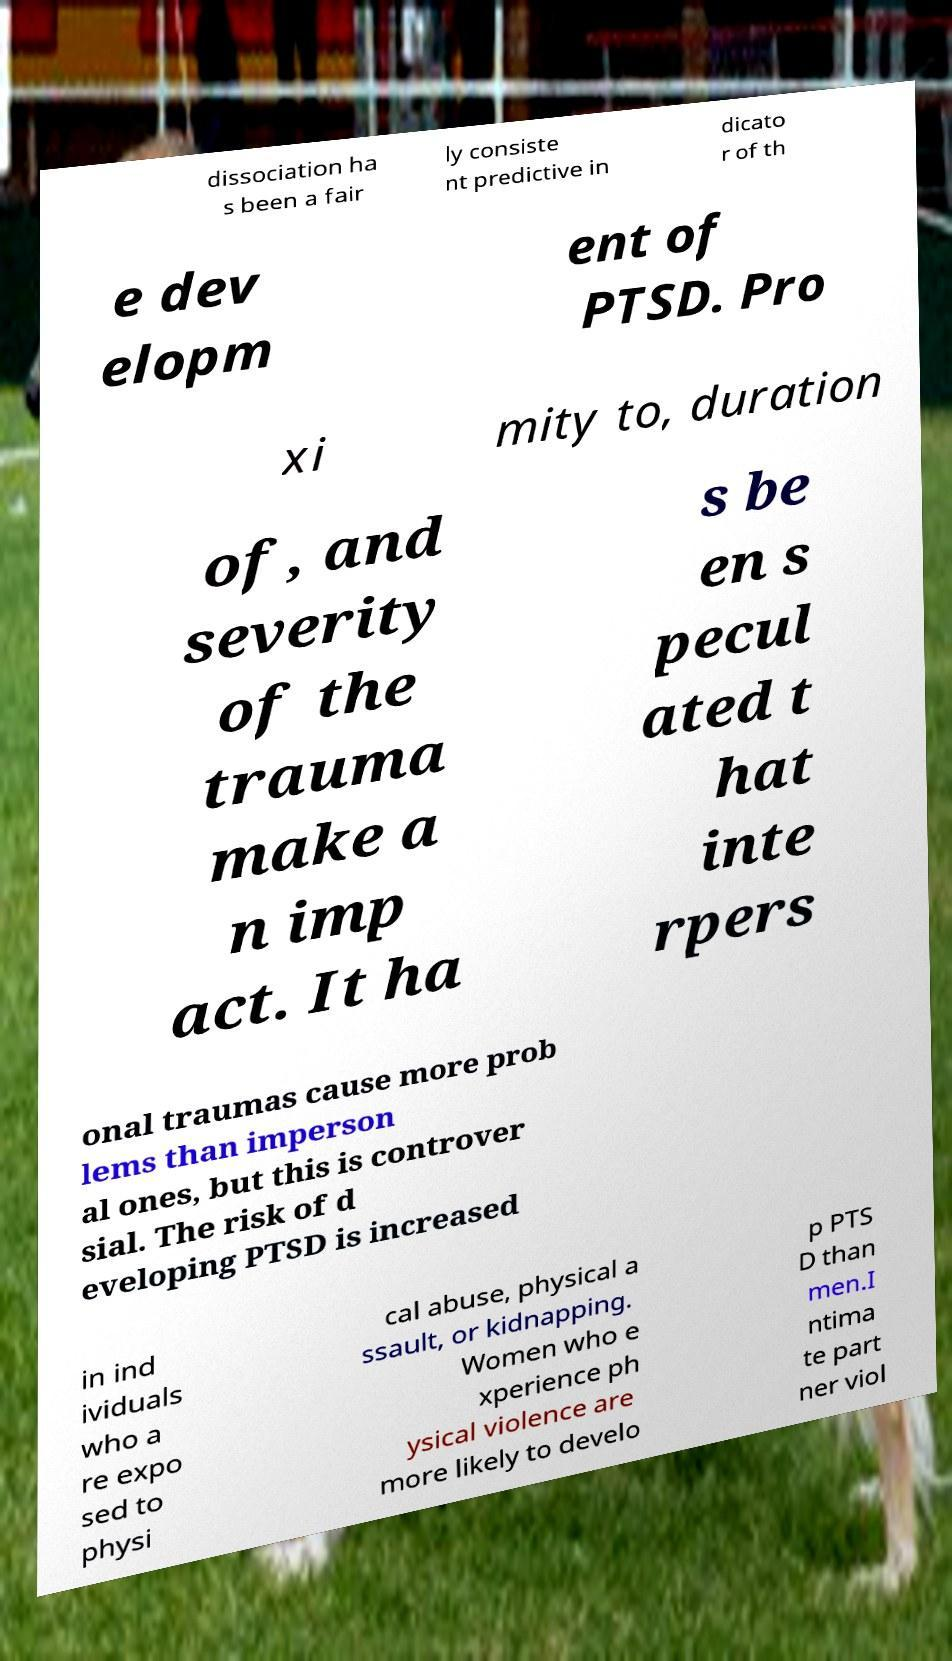For documentation purposes, I need the text within this image transcribed. Could you provide that? dissociation ha s been a fair ly consiste nt predictive in dicato r of th e dev elopm ent of PTSD. Pro xi mity to, duration of, and severity of the trauma make a n imp act. It ha s be en s pecul ated t hat inte rpers onal traumas cause more prob lems than imperson al ones, but this is controver sial. The risk of d eveloping PTSD is increased in ind ividuals who a re expo sed to physi cal abuse, physical a ssault, or kidnapping. Women who e xperience ph ysical violence are more likely to develo p PTS D than men.I ntima te part ner viol 